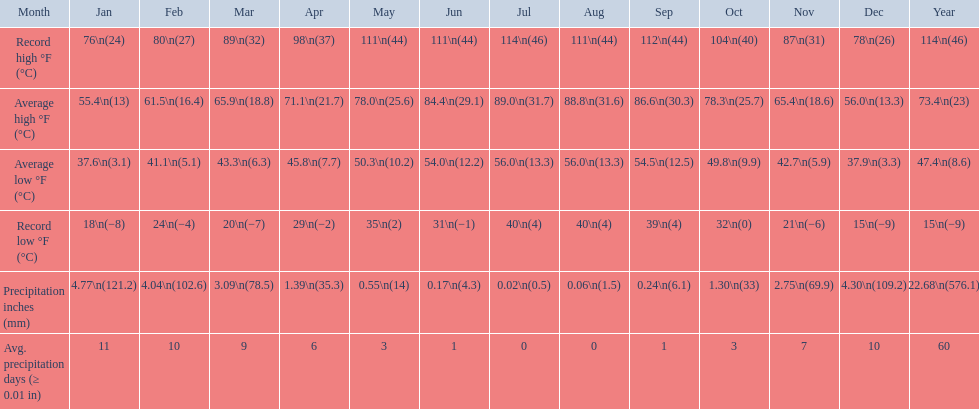0 degrees and the average low temperature drop to 5 July. 